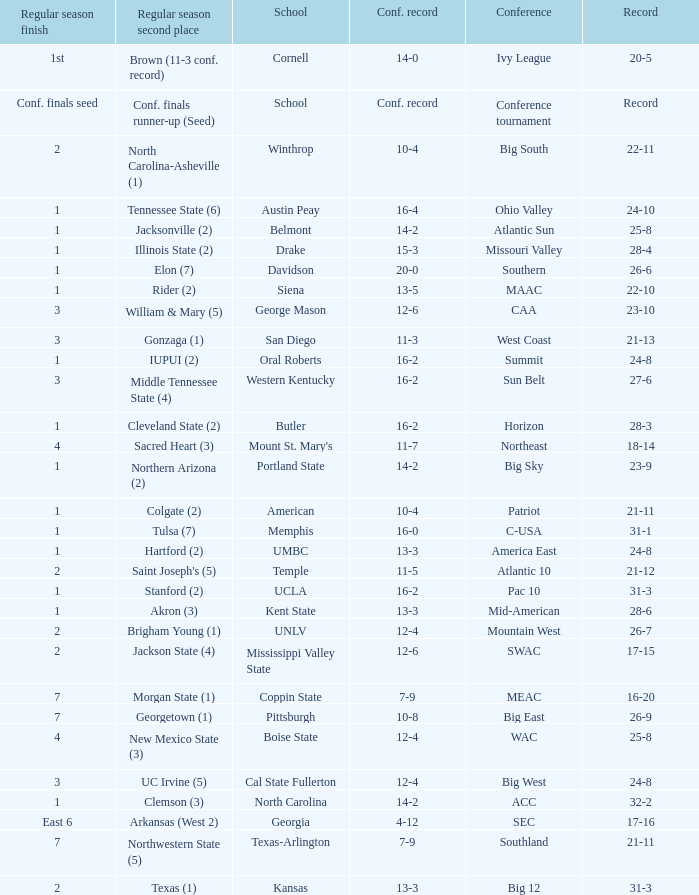For teams in the Sun Belt conference, what is the conference record? 16-2. Would you be able to parse every entry in this table? {'header': ['Regular season finish', 'Regular season second place', 'School', 'Conf. record', 'Conference', 'Record'], 'rows': [['1st', 'Brown (11-3 conf. record)', 'Cornell', '14-0', 'Ivy League', '20-5'], ['Conf. finals seed', 'Conf. finals runner-up (Seed)', 'School', 'Conf. record', 'Conference tournament', 'Record'], ['2', 'North Carolina-Asheville (1)', 'Winthrop', '10-4', 'Big South', '22-11'], ['1', 'Tennessee State (6)', 'Austin Peay', '16-4', 'Ohio Valley', '24-10'], ['1', 'Jacksonville (2)', 'Belmont', '14-2', 'Atlantic Sun', '25-8'], ['1', 'Illinois State (2)', 'Drake', '15-3', 'Missouri Valley', '28-4'], ['1', 'Elon (7)', 'Davidson', '20-0', 'Southern', '26-6'], ['1', 'Rider (2)', 'Siena', '13-5', 'MAAC', '22-10'], ['3', 'William & Mary (5)', 'George Mason', '12-6', 'CAA', '23-10'], ['3', 'Gonzaga (1)', 'San Diego', '11-3', 'West Coast', '21-13'], ['1', 'IUPUI (2)', 'Oral Roberts', '16-2', 'Summit', '24-8'], ['3', 'Middle Tennessee State (4)', 'Western Kentucky', '16-2', 'Sun Belt', '27-6'], ['1', 'Cleveland State (2)', 'Butler', '16-2', 'Horizon', '28-3'], ['4', 'Sacred Heart (3)', "Mount St. Mary's", '11-7', 'Northeast', '18-14'], ['1', 'Northern Arizona (2)', 'Portland State', '14-2', 'Big Sky', '23-9'], ['1', 'Colgate (2)', 'American', '10-4', 'Patriot', '21-11'], ['1', 'Tulsa (7)', 'Memphis', '16-0', 'C-USA', '31-1'], ['1', 'Hartford (2)', 'UMBC', '13-3', 'America East', '24-8'], ['2', "Saint Joseph's (5)", 'Temple', '11-5', 'Atlantic 10', '21-12'], ['1', 'Stanford (2)', 'UCLA', '16-2', 'Pac 10', '31-3'], ['1', 'Akron (3)', 'Kent State', '13-3', 'Mid-American', '28-6'], ['2', 'Brigham Young (1)', 'UNLV', '12-4', 'Mountain West', '26-7'], ['2', 'Jackson State (4)', 'Mississippi Valley State', '12-6', 'SWAC', '17-15'], ['7', 'Morgan State (1)', 'Coppin State', '7-9', 'MEAC', '16-20'], ['7', 'Georgetown (1)', 'Pittsburgh', '10-8', 'Big East', '26-9'], ['4', 'New Mexico State (3)', 'Boise State', '12-4', 'WAC', '25-8'], ['3', 'UC Irvine (5)', 'Cal State Fullerton', '12-4', 'Big West', '24-8'], ['1', 'Clemson (3)', 'North Carolina', '14-2', 'ACC', '32-2'], ['East 6', 'Arkansas (West 2)', 'Georgia', '4-12', 'SEC', '17-16'], ['7', 'Northwestern State (5)', 'Texas-Arlington', '7-9', 'Southland', '21-11'], ['2', 'Texas (1)', 'Kansas', '13-3', 'Big 12', '31-3']]} 